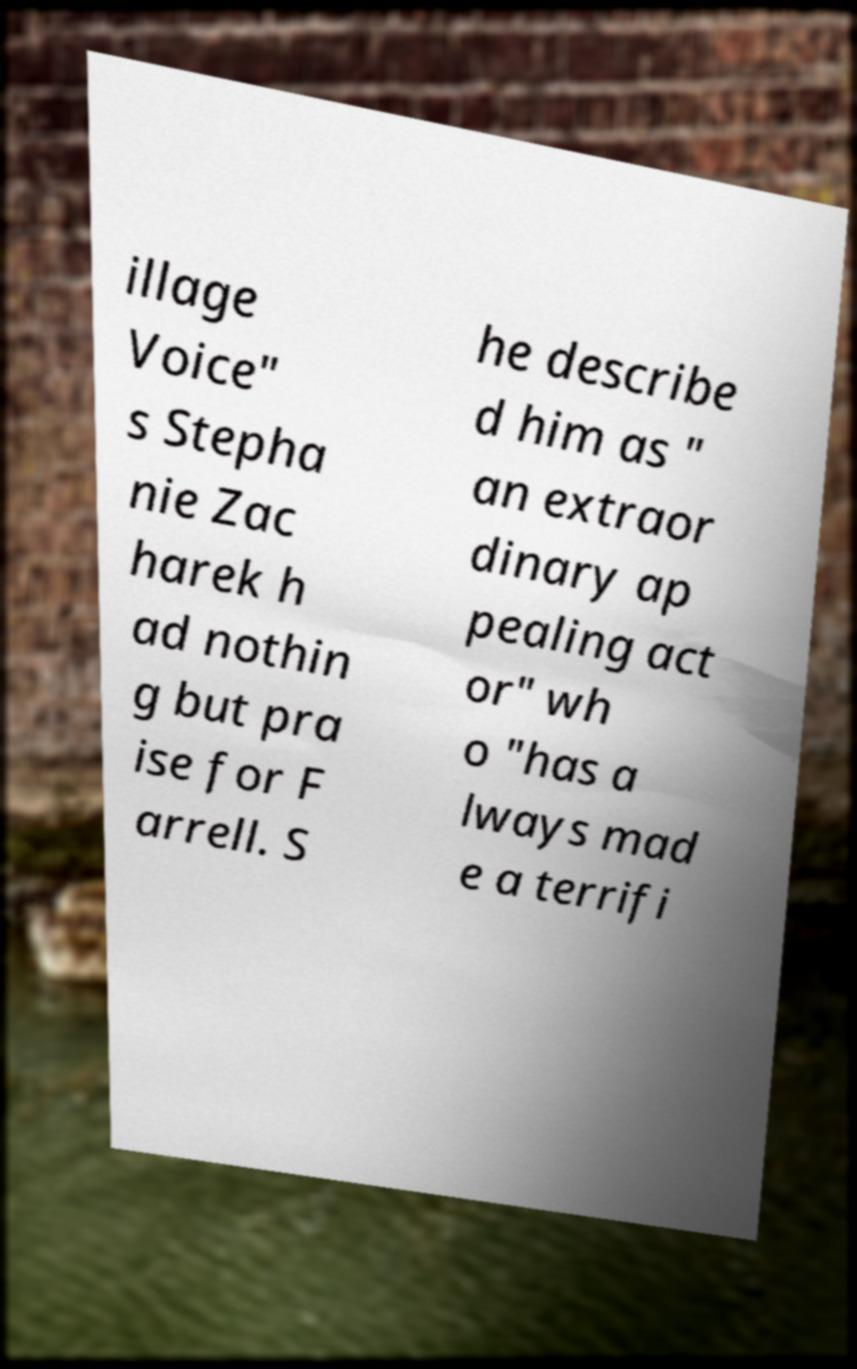Could you extract and type out the text from this image? illage Voice" s Stepha nie Zac harek h ad nothin g but pra ise for F arrell. S he describe d him as " an extraor dinary ap pealing act or" wh o "has a lways mad e a terrifi 